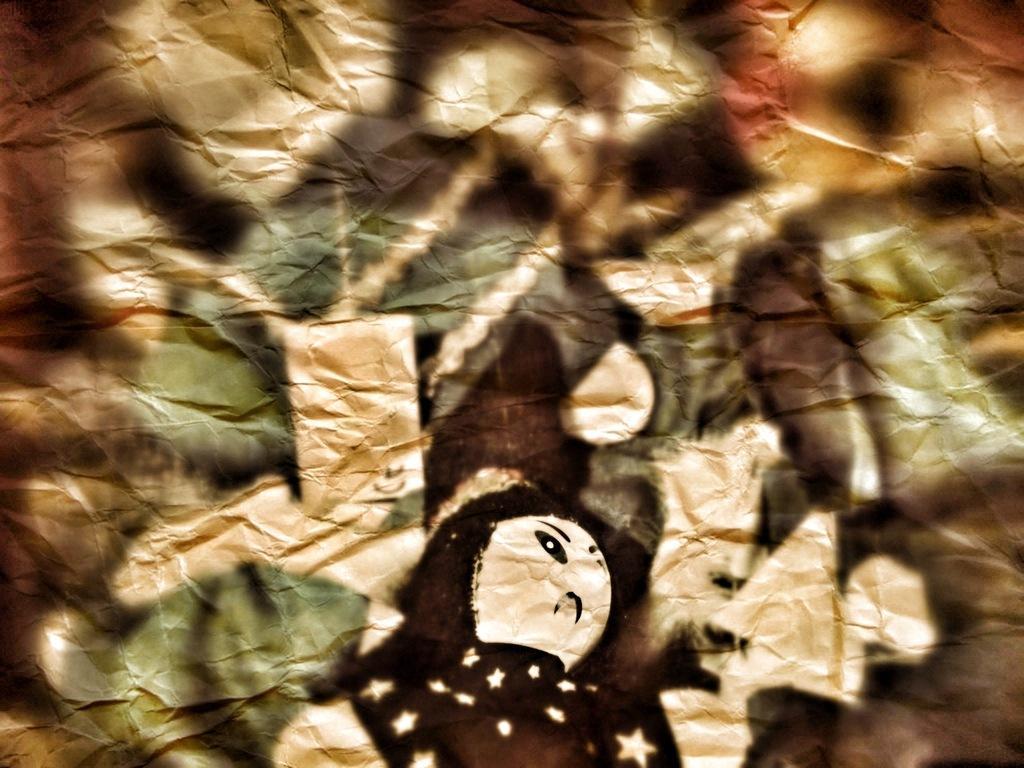Please provide a concise description of this image. This picture looks like a painting on the paper. 